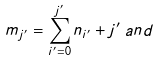Convert formula to latex. <formula><loc_0><loc_0><loc_500><loc_500>m _ { j ^ { \prime } } = \sum ^ { j ^ { \prime } } _ { i ^ { \prime } = 0 } n _ { i ^ { \prime } } + j ^ { \prime } \, a n d</formula> 